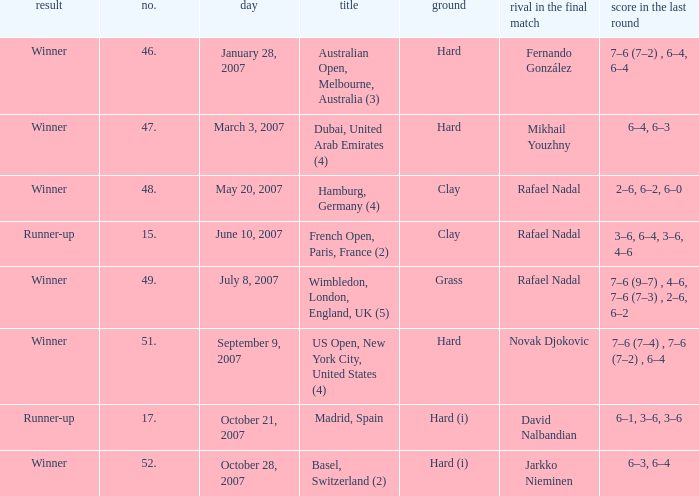When the surface is hard (i) and the outcome is a victory, what is the no.? 52.0. 